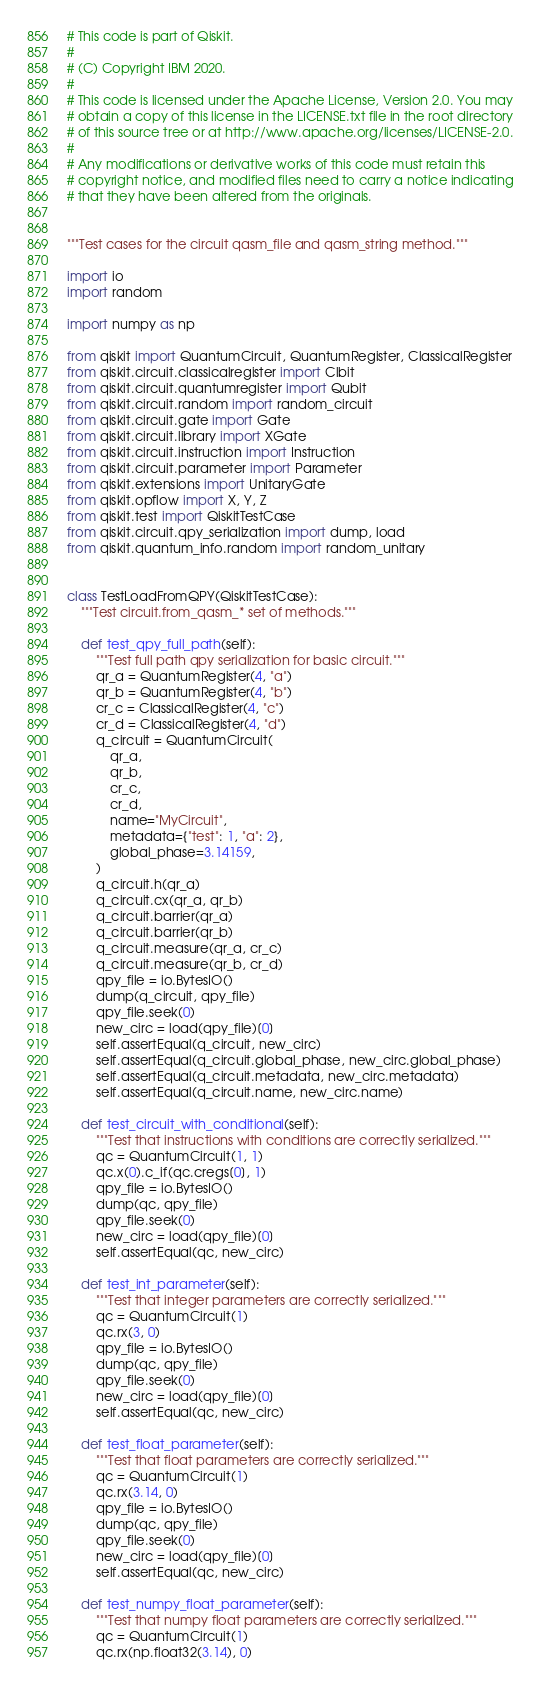<code> <loc_0><loc_0><loc_500><loc_500><_Python_># This code is part of Qiskit.
#
# (C) Copyright IBM 2020.
#
# This code is licensed under the Apache License, Version 2.0. You may
# obtain a copy of this license in the LICENSE.txt file in the root directory
# of this source tree or at http://www.apache.org/licenses/LICENSE-2.0.
#
# Any modifications or derivative works of this code must retain this
# copyright notice, and modified files need to carry a notice indicating
# that they have been altered from the originals.


"""Test cases for the circuit qasm_file and qasm_string method."""

import io
import random

import numpy as np

from qiskit import QuantumCircuit, QuantumRegister, ClassicalRegister
from qiskit.circuit.classicalregister import Clbit
from qiskit.circuit.quantumregister import Qubit
from qiskit.circuit.random import random_circuit
from qiskit.circuit.gate import Gate
from qiskit.circuit.library import XGate
from qiskit.circuit.instruction import Instruction
from qiskit.circuit.parameter import Parameter
from qiskit.extensions import UnitaryGate
from qiskit.opflow import X, Y, Z
from qiskit.test import QiskitTestCase
from qiskit.circuit.qpy_serialization import dump, load
from qiskit.quantum_info.random import random_unitary


class TestLoadFromQPY(QiskitTestCase):
    """Test circuit.from_qasm_* set of methods."""

    def test_qpy_full_path(self):
        """Test full path qpy serialization for basic circuit."""
        qr_a = QuantumRegister(4, "a")
        qr_b = QuantumRegister(4, "b")
        cr_c = ClassicalRegister(4, "c")
        cr_d = ClassicalRegister(4, "d")
        q_circuit = QuantumCircuit(
            qr_a,
            qr_b,
            cr_c,
            cr_d,
            name="MyCircuit",
            metadata={"test": 1, "a": 2},
            global_phase=3.14159,
        )
        q_circuit.h(qr_a)
        q_circuit.cx(qr_a, qr_b)
        q_circuit.barrier(qr_a)
        q_circuit.barrier(qr_b)
        q_circuit.measure(qr_a, cr_c)
        q_circuit.measure(qr_b, cr_d)
        qpy_file = io.BytesIO()
        dump(q_circuit, qpy_file)
        qpy_file.seek(0)
        new_circ = load(qpy_file)[0]
        self.assertEqual(q_circuit, new_circ)
        self.assertEqual(q_circuit.global_phase, new_circ.global_phase)
        self.assertEqual(q_circuit.metadata, new_circ.metadata)
        self.assertEqual(q_circuit.name, new_circ.name)

    def test_circuit_with_conditional(self):
        """Test that instructions with conditions are correctly serialized."""
        qc = QuantumCircuit(1, 1)
        qc.x(0).c_if(qc.cregs[0], 1)
        qpy_file = io.BytesIO()
        dump(qc, qpy_file)
        qpy_file.seek(0)
        new_circ = load(qpy_file)[0]
        self.assertEqual(qc, new_circ)

    def test_int_parameter(self):
        """Test that integer parameters are correctly serialized."""
        qc = QuantumCircuit(1)
        qc.rx(3, 0)
        qpy_file = io.BytesIO()
        dump(qc, qpy_file)
        qpy_file.seek(0)
        new_circ = load(qpy_file)[0]
        self.assertEqual(qc, new_circ)

    def test_float_parameter(self):
        """Test that float parameters are correctly serialized."""
        qc = QuantumCircuit(1)
        qc.rx(3.14, 0)
        qpy_file = io.BytesIO()
        dump(qc, qpy_file)
        qpy_file.seek(0)
        new_circ = load(qpy_file)[0]
        self.assertEqual(qc, new_circ)

    def test_numpy_float_parameter(self):
        """Test that numpy float parameters are correctly serialized."""
        qc = QuantumCircuit(1)
        qc.rx(np.float32(3.14), 0)</code> 